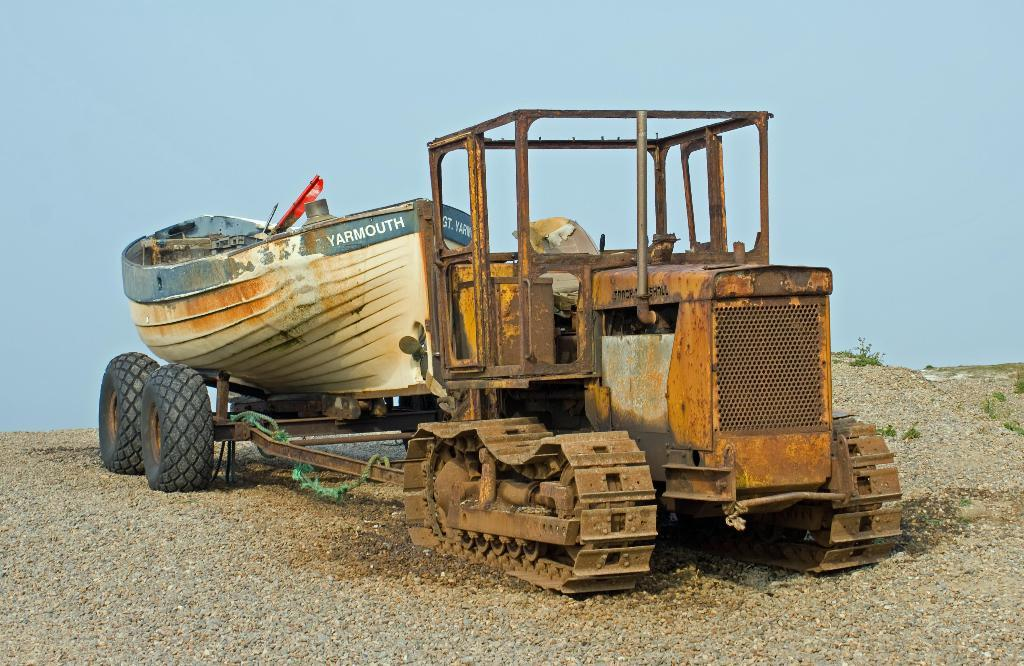What is the main subject of the image? The main subject of the image is a bulldozer. Can you describe the position of the bulldozer in the image? The bulldozer is on the ground in the image. What can be seen in the background of the image? There is sky visible in the background of the image. How many feet are visible in the image? There are no feet visible in the image; it features a bulldozer on the ground. What type of winter clothing is the bulldozer wearing in the image? There is no winter clothing present in the image, as it features a bulldozer on the ground. 